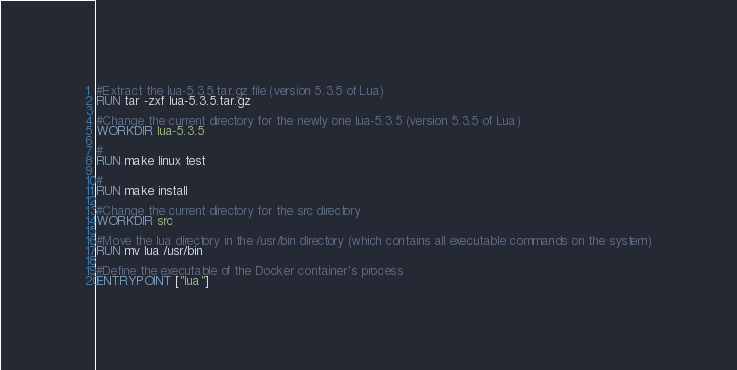<code> <loc_0><loc_0><loc_500><loc_500><_Dockerfile_>#Extract the lua-5.3.5.tar.gz file (version 5.3.5 of Lua)
RUN tar -zxf lua-5.3.5.tar.gz

#Change the current directory for the newly one lua-5.3.5 (version 5.3.5 of Lua)
WORKDIR lua-5.3.5

#
RUN make linux test

#
RUN make install

#Change the current directory for the src directory
WORKDIR src

#Move the lua directory in the /usr/bin directory (which contains all executable commands on the system)
RUN mv lua /usr/bin

#Define the executable of the Docker container's process
ENTRYPOINT ["lua"]
</code> 